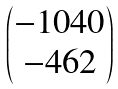Convert formula to latex. <formula><loc_0><loc_0><loc_500><loc_500>\begin{pmatrix} - 1 0 4 0 \\ - 4 6 2 \end{pmatrix}</formula> 